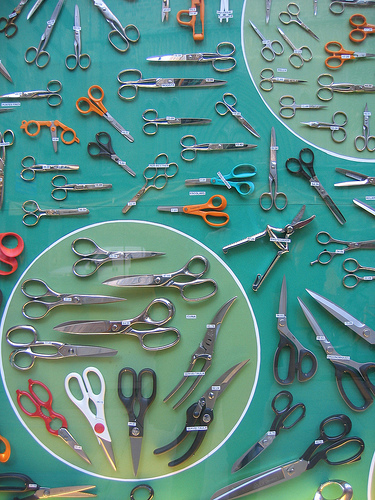What color is the mat? The mat is light blue. 